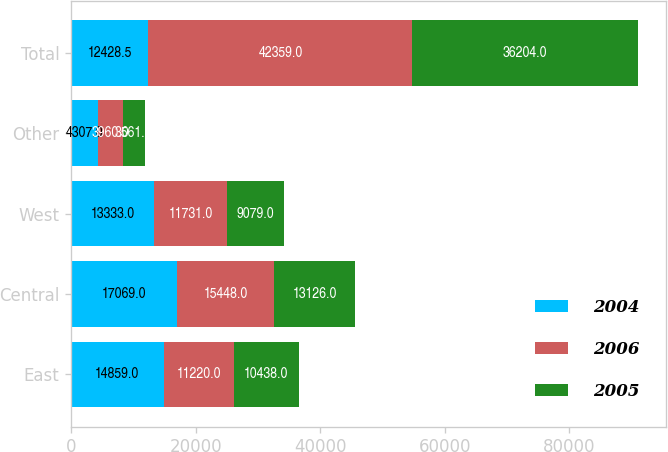Convert chart. <chart><loc_0><loc_0><loc_500><loc_500><stacked_bar_chart><ecel><fcel>East<fcel>Central<fcel>West<fcel>Other<fcel>Total<nl><fcel>2004<fcel>14859<fcel>17069<fcel>13333<fcel>4307<fcel>12428.5<nl><fcel>2006<fcel>11220<fcel>15448<fcel>11731<fcel>3960<fcel>42359<nl><fcel>2005<fcel>10438<fcel>13126<fcel>9079<fcel>3561<fcel>36204<nl></chart> 